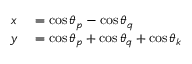Convert formula to latex. <formula><loc_0><loc_0><loc_500><loc_500>\begin{array} { r l } { x } & = \cos \theta _ { p } - \cos \theta _ { q } } \\ { y } & = \cos \theta _ { p } + \cos \theta _ { q } + \cos \theta _ { k } } \end{array}</formula> 